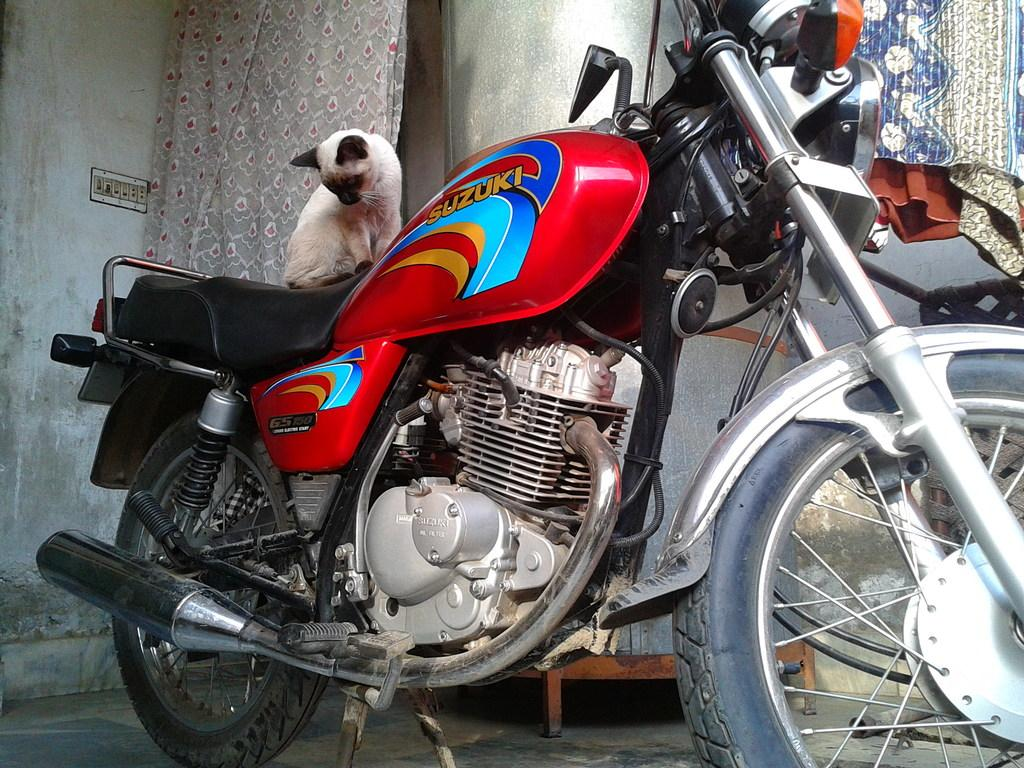What type of vehicle is in the image? There is a red color motorcycle in the image. What is sitting on the motorcycle? A pussycat is sitting on the motorcycle. What can be seen in the background of the image? There is a wall and a switch board in the background of the image. How does the minister balance on the motorcycle in the image? There is no minister present in the image; it features a pussycat sitting on the motorcycle. 